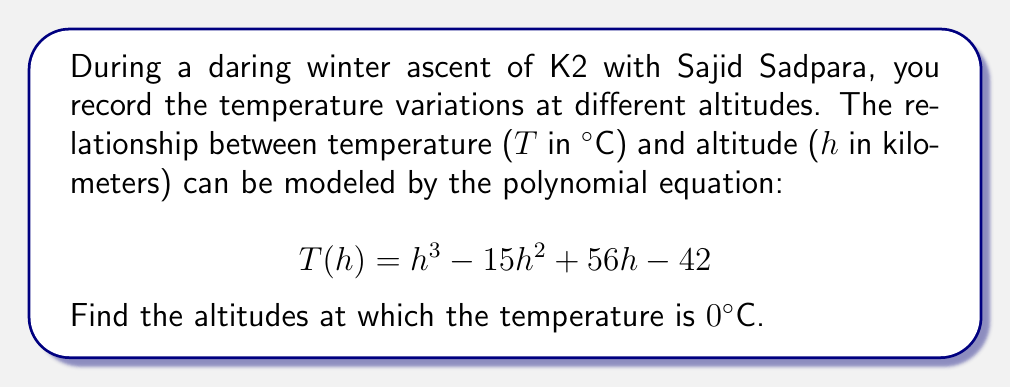Teach me how to tackle this problem. To find the altitudes where the temperature is 0°C, we need to solve the equation:

$$T(h) = h^3 - 15h^2 + 56h - 42 = 0$$

This is a cubic equation. Let's solve it step by step:

1) First, let's check if there are any rational roots using the rational root theorem. The possible rational roots are the factors of the constant term 42: ±1, ±2, ±3, ±6, ±7, ±14, ±21, ±42.

2) Testing these values, we find that h = 3 is a root. So (h - 3) is a factor.

3) We can divide the polynomial by (h - 3):

   $$(h^3 - 15h^2 + 56h - 42) ÷ (h - 3) = h^2 - 12h + 14$$

4) Now our equation becomes:

   $$(h - 3)(h^2 - 12h + 14) = 0$$

5) We can solve $h^2 - 12h + 14 = 0$ using the quadratic formula:

   $$h = \frac{-b \pm \sqrt{b^2 - 4ac}}{2a}$$

   Where $a = 1$, $b = -12$, and $c = 14$

6) Substituting these values:

   $$h = \frac{12 \pm \sqrt{144 - 56}}{2} = \frac{12 \pm \sqrt{88}}{2} = \frac{12 \pm 2\sqrt{22}}{2}$$

7) Simplifying:

   $$h = 6 \pm \sqrt{22}$$

Therefore, the three roots are:

$$h_1 = 3$$
$$h_2 = 6 + \sqrt{22} \approx 10.69$$
$$h_3 = 6 - \sqrt{22} \approx 1.31$$

These are the altitudes (in km) where the temperature is 0°C according to the model.
Answer: The temperature is 0°C at altitudes of approximately 1.31 km, 3 km, and 10.69 km. 